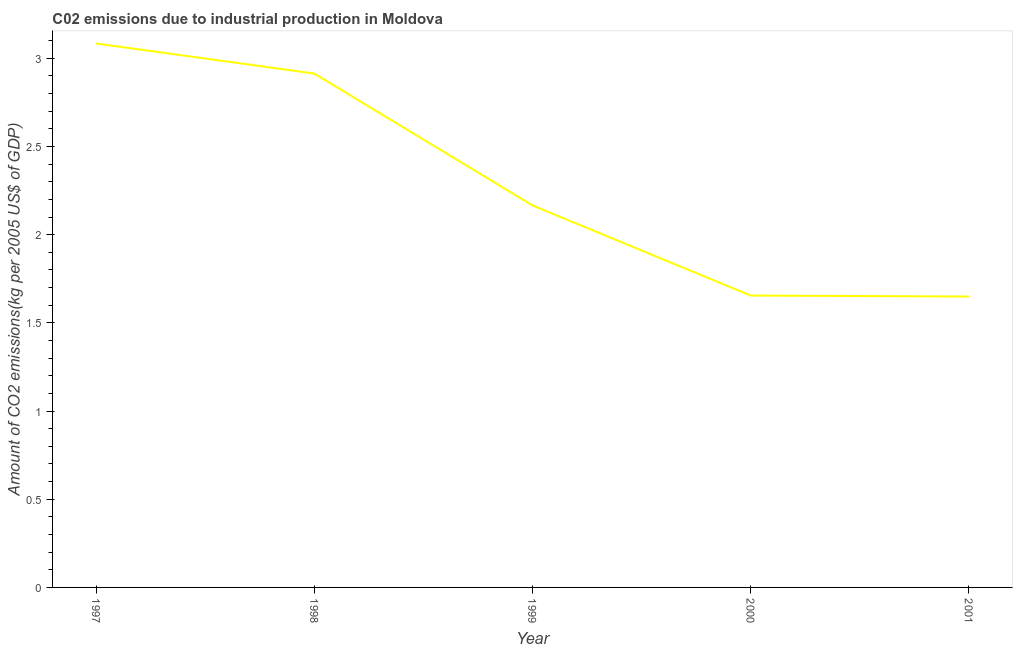What is the amount of co2 emissions in 1999?
Make the answer very short. 2.17. Across all years, what is the maximum amount of co2 emissions?
Provide a succinct answer. 3.08. Across all years, what is the minimum amount of co2 emissions?
Provide a short and direct response. 1.65. In which year was the amount of co2 emissions minimum?
Your response must be concise. 2001. What is the sum of the amount of co2 emissions?
Provide a succinct answer. 11.47. What is the difference between the amount of co2 emissions in 1998 and 2001?
Give a very brief answer. 1.26. What is the average amount of co2 emissions per year?
Provide a succinct answer. 2.29. What is the median amount of co2 emissions?
Ensure brevity in your answer.  2.17. In how many years, is the amount of co2 emissions greater than 1.1 kg per 2005 US$ of GDP?
Give a very brief answer. 5. What is the ratio of the amount of co2 emissions in 1997 to that in 1999?
Offer a very short reply. 1.42. Is the amount of co2 emissions in 1997 less than that in 2001?
Your answer should be very brief. No. Is the difference between the amount of co2 emissions in 1998 and 2000 greater than the difference between any two years?
Your answer should be compact. No. What is the difference between the highest and the second highest amount of co2 emissions?
Keep it short and to the point. 0.17. Is the sum of the amount of co2 emissions in 1999 and 2001 greater than the maximum amount of co2 emissions across all years?
Offer a terse response. Yes. What is the difference between the highest and the lowest amount of co2 emissions?
Your answer should be very brief. 1.43. Does the amount of co2 emissions monotonically increase over the years?
Your answer should be very brief. No. How many lines are there?
Your answer should be very brief. 1. Are the values on the major ticks of Y-axis written in scientific E-notation?
Provide a short and direct response. No. What is the title of the graph?
Make the answer very short. C02 emissions due to industrial production in Moldova. What is the label or title of the X-axis?
Ensure brevity in your answer.  Year. What is the label or title of the Y-axis?
Ensure brevity in your answer.  Amount of CO2 emissions(kg per 2005 US$ of GDP). What is the Amount of CO2 emissions(kg per 2005 US$ of GDP) in 1997?
Give a very brief answer. 3.08. What is the Amount of CO2 emissions(kg per 2005 US$ of GDP) of 1998?
Provide a succinct answer. 2.91. What is the Amount of CO2 emissions(kg per 2005 US$ of GDP) in 1999?
Offer a very short reply. 2.17. What is the Amount of CO2 emissions(kg per 2005 US$ of GDP) of 2000?
Make the answer very short. 1.65. What is the Amount of CO2 emissions(kg per 2005 US$ of GDP) of 2001?
Ensure brevity in your answer.  1.65. What is the difference between the Amount of CO2 emissions(kg per 2005 US$ of GDP) in 1997 and 1998?
Provide a succinct answer. 0.17. What is the difference between the Amount of CO2 emissions(kg per 2005 US$ of GDP) in 1997 and 1999?
Make the answer very short. 0.92. What is the difference between the Amount of CO2 emissions(kg per 2005 US$ of GDP) in 1997 and 2000?
Make the answer very short. 1.43. What is the difference between the Amount of CO2 emissions(kg per 2005 US$ of GDP) in 1997 and 2001?
Your answer should be very brief. 1.43. What is the difference between the Amount of CO2 emissions(kg per 2005 US$ of GDP) in 1998 and 1999?
Your response must be concise. 0.75. What is the difference between the Amount of CO2 emissions(kg per 2005 US$ of GDP) in 1998 and 2000?
Make the answer very short. 1.26. What is the difference between the Amount of CO2 emissions(kg per 2005 US$ of GDP) in 1998 and 2001?
Ensure brevity in your answer.  1.26. What is the difference between the Amount of CO2 emissions(kg per 2005 US$ of GDP) in 1999 and 2000?
Offer a terse response. 0.51. What is the difference between the Amount of CO2 emissions(kg per 2005 US$ of GDP) in 1999 and 2001?
Make the answer very short. 0.52. What is the difference between the Amount of CO2 emissions(kg per 2005 US$ of GDP) in 2000 and 2001?
Offer a terse response. 0.01. What is the ratio of the Amount of CO2 emissions(kg per 2005 US$ of GDP) in 1997 to that in 1998?
Your answer should be very brief. 1.06. What is the ratio of the Amount of CO2 emissions(kg per 2005 US$ of GDP) in 1997 to that in 1999?
Your answer should be compact. 1.42. What is the ratio of the Amount of CO2 emissions(kg per 2005 US$ of GDP) in 1997 to that in 2000?
Provide a succinct answer. 1.86. What is the ratio of the Amount of CO2 emissions(kg per 2005 US$ of GDP) in 1997 to that in 2001?
Your response must be concise. 1.87. What is the ratio of the Amount of CO2 emissions(kg per 2005 US$ of GDP) in 1998 to that in 1999?
Keep it short and to the point. 1.34. What is the ratio of the Amount of CO2 emissions(kg per 2005 US$ of GDP) in 1998 to that in 2000?
Provide a succinct answer. 1.76. What is the ratio of the Amount of CO2 emissions(kg per 2005 US$ of GDP) in 1998 to that in 2001?
Make the answer very short. 1.77. What is the ratio of the Amount of CO2 emissions(kg per 2005 US$ of GDP) in 1999 to that in 2000?
Your answer should be compact. 1.31. What is the ratio of the Amount of CO2 emissions(kg per 2005 US$ of GDP) in 1999 to that in 2001?
Offer a terse response. 1.31. 